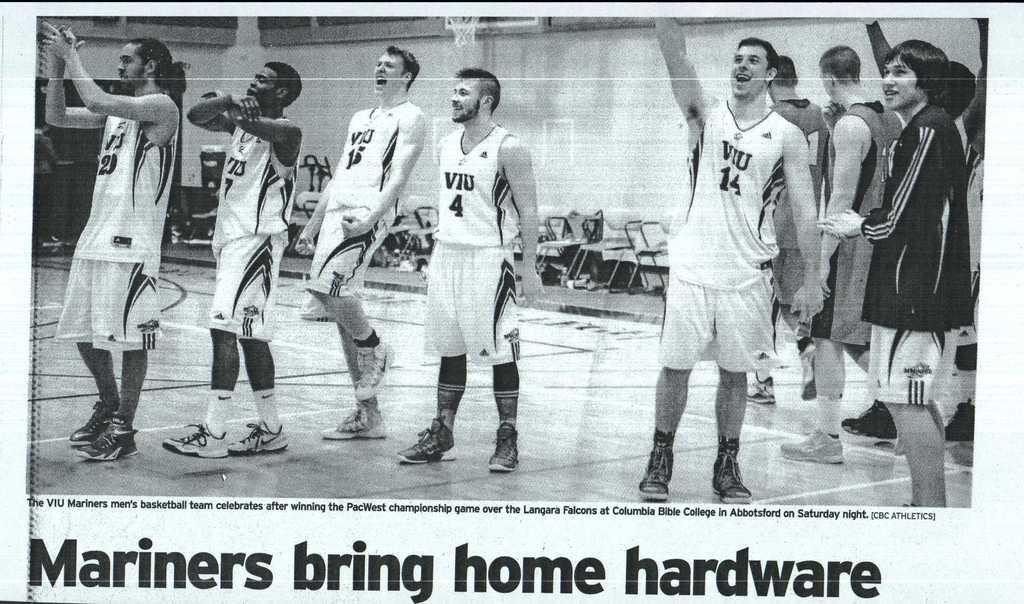What is the main object in the image? There is a paper in the image. What can be seen on the paper? The paper contains images of men. Are there any other objects or furniture in the image? Yes, there are empty chairs in the image. What else is present on the paper besides the images of men? There is text on the paper. How does the organization of the men in the images on the paper affect their ability to walk? The organization of the men in the images on the paper does not affect their ability to walk, as they are not real people and the image is static. 